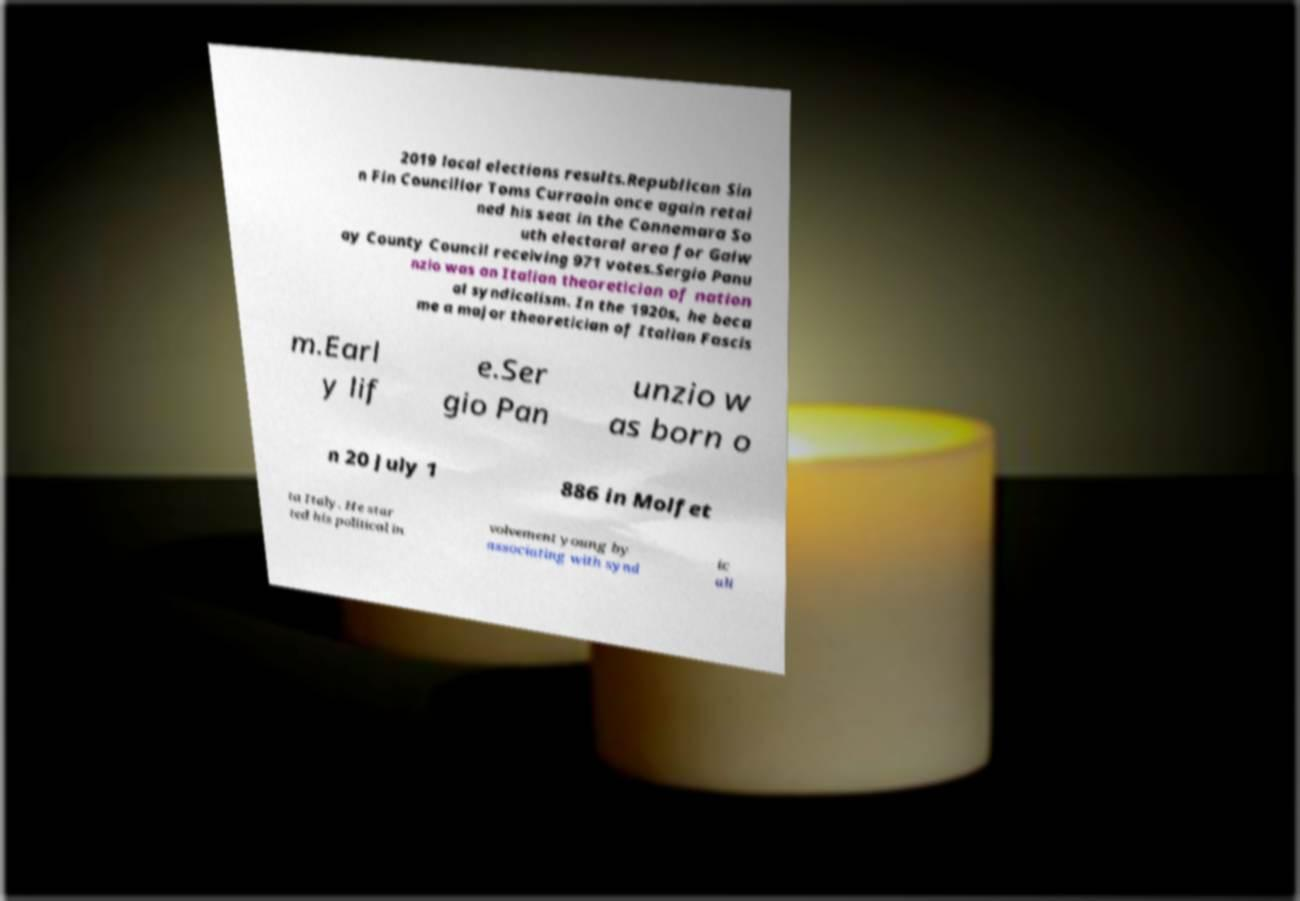Please identify and transcribe the text found in this image. 2019 local elections results.Republican Sin n Fin Councillor Toms Curraoin once again retai ned his seat in the Connemara So uth electoral area for Galw ay County Council receiving 971 votes.Sergio Panu nzio was an Italian theoretician of nation al syndicalism. In the 1920s, he beca me a major theoretician of Italian Fascis m.Earl y lif e.Ser gio Pan unzio w as born o n 20 July 1 886 in Molfet ta Italy. He star ted his political in volvement young by associating with synd ic ali 